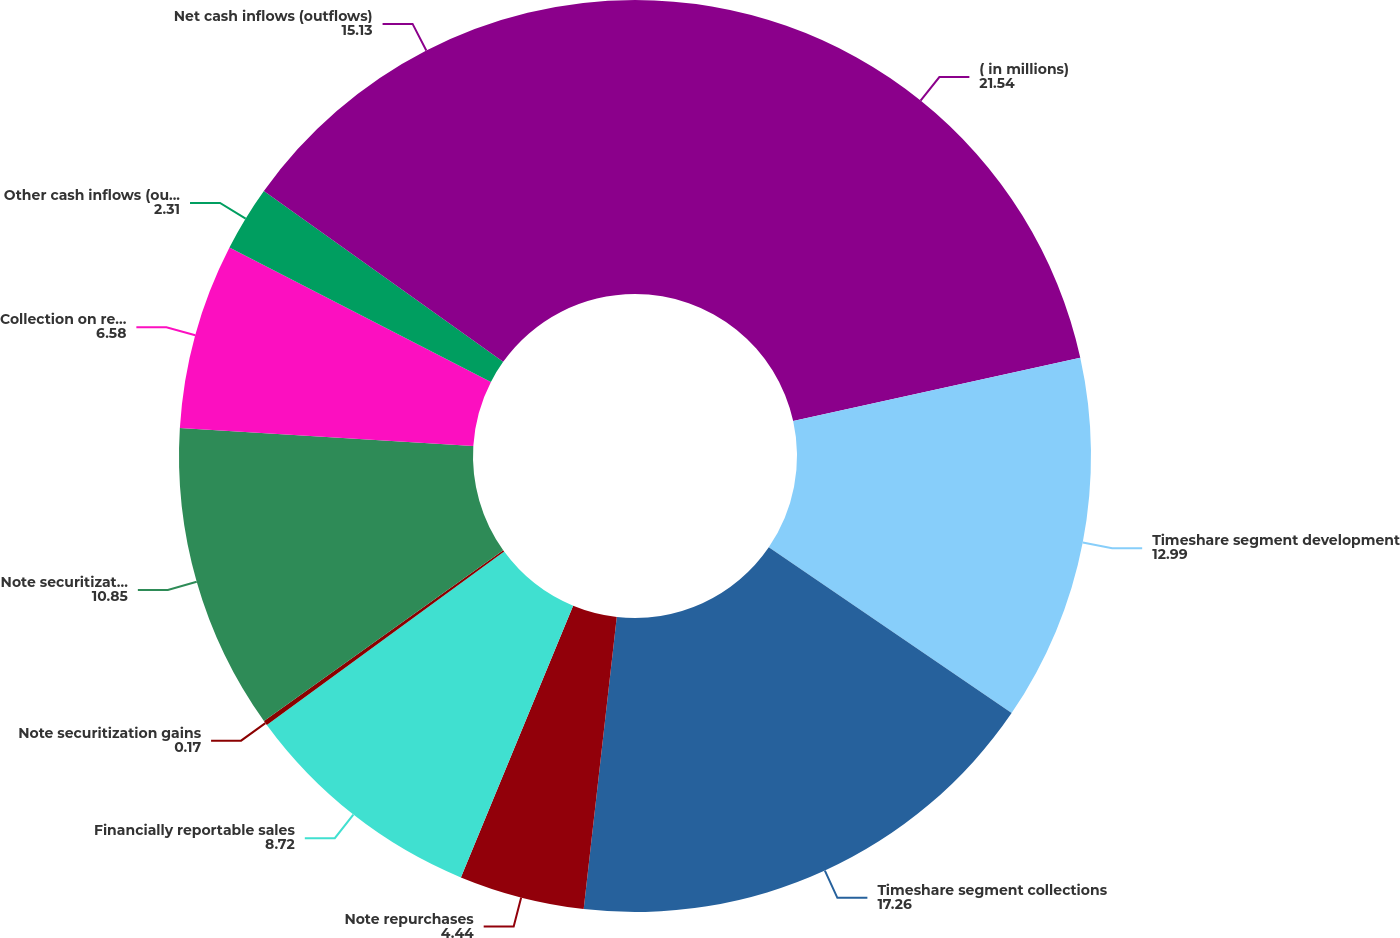Convert chart to OTSL. <chart><loc_0><loc_0><loc_500><loc_500><pie_chart><fcel>( in millions)<fcel>Timeshare segment development<fcel>Timeshare segment collections<fcel>Note repurchases<fcel>Financially reportable sales<fcel>Note securitization gains<fcel>Note securitization proceeds<fcel>Collection on retained<fcel>Other cash inflows (outflows)<fcel>Net cash inflows (outflows)<nl><fcel>21.54%<fcel>12.99%<fcel>17.26%<fcel>4.44%<fcel>8.72%<fcel>0.17%<fcel>10.85%<fcel>6.58%<fcel>2.31%<fcel>15.13%<nl></chart> 